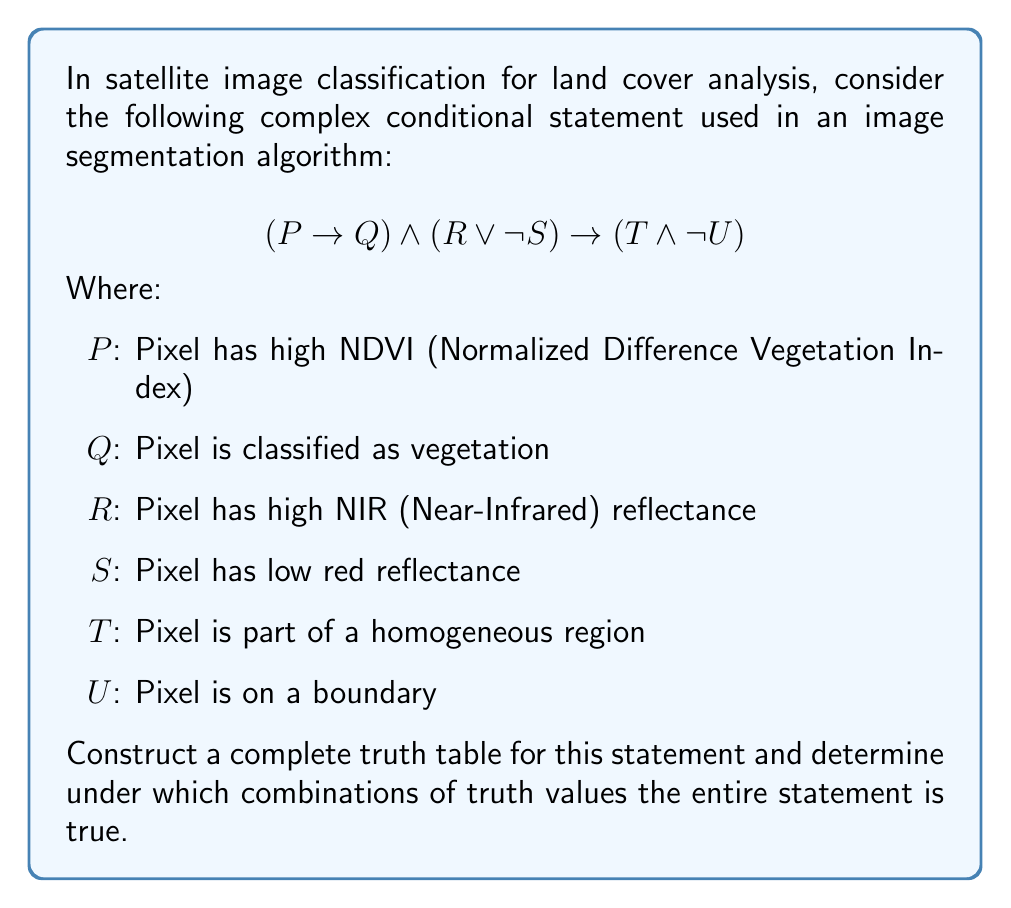Give your solution to this math problem. To construct the truth table for this complex conditional statement, we'll follow these steps:

1) Identify the atomic propositions: P, Q, R, S, T, and U.

2) List all possible combinations of truth values for these propositions (64 rows for 6 variables).

3) Evaluate the sub-expressions:
   a) $P \rightarrow Q$
   b) $R \vee \neg S$
   c) $T \wedge \neg U$

4) Evaluate the main implication:
   $((P \rightarrow Q) \wedge (R \vee \neg S)) \rightarrow (T \wedge \neg U)$

5) Identify the rows where the entire statement is true.

Here's a partial truth table to illustrate the process:

$$
\begin{array}{cccccc|ccc|c}
P & Q & R & S & T & U & P \rightarrow Q & R \vee \neg S & T \wedge \neg U & \text{Result} \\
\hline
T & T & T & T & T & T & T & T & F & T \\
T & T & T & T & T & F & T & T & T & T \\
T & T & T & T & F & T & T & T & F & T \\
T & T & T & T & F & F & T & T & F & T \\
T & T & T & F & T & T & T & T & F & T \\
\vdots & \vdots & \vdots & \vdots & \vdots & \vdots & \vdots & \vdots & \vdots & \vdots
\end{array}
$$

The entire truth table would have 64 rows. The statement is true when:

1) The antecedent $((P \rightarrow Q) \wedge (R \vee \neg S))$ is false, or
2) Both the antecedent and consequent $(T \wedge \neg U)$ are true.

After evaluating all rows, we find that the statement is true in 56 out of 64 cases.
Answer: The complex conditional statement is true in 56 out of 64 possible combinations of truth values for P, Q, R, S, T, and U. 